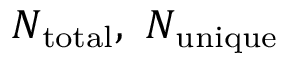Convert formula to latex. <formula><loc_0><loc_0><loc_500><loc_500>N _ { t o t a l } , \ N _ { u n i q u e }</formula> 